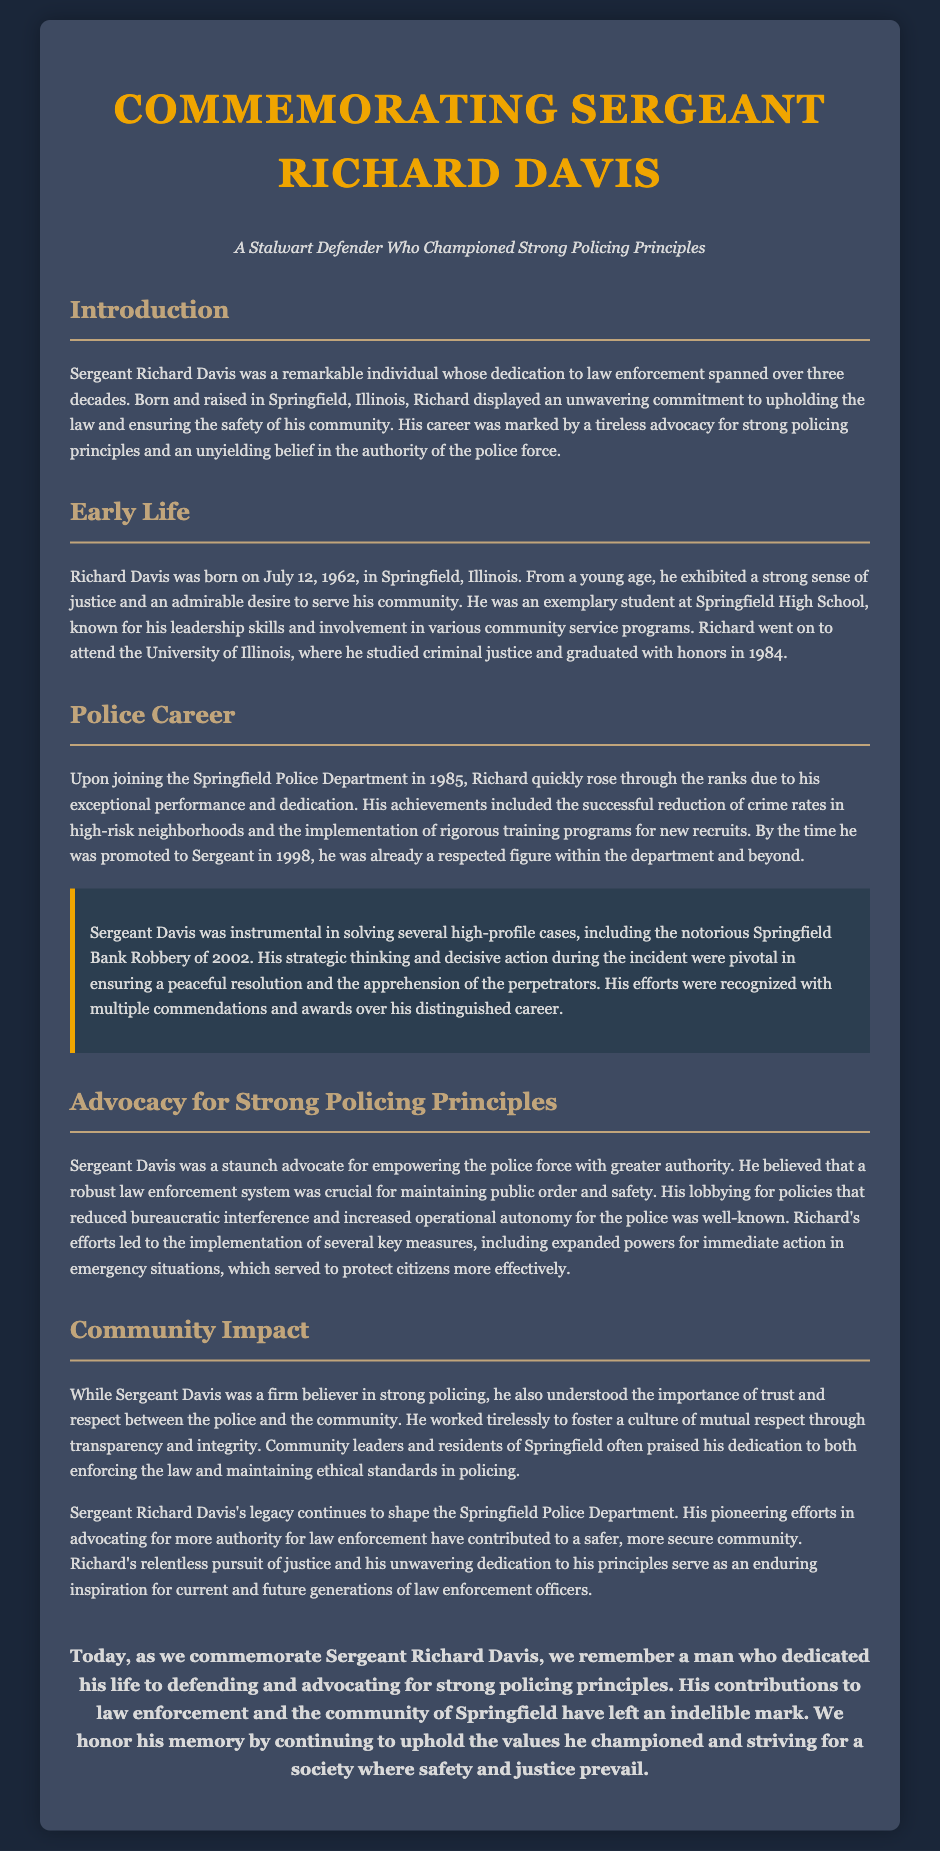what date was Sergeant Richard Davis born? The document states that Sergeant Richard Davis was born on July 12, 1962.
Answer: July 12, 1962 what was Sergeant Davis's profession? The document identifies Sergeant Richard Davis as a member of the Springfield Police Department and a Sergeant.
Answer: Sergeant what year did Sergeant Davis join the Springfield Police Department? The document mentions that he joined the department in 1985.
Answer: 1985 which high-profile case did Sergeant Davis solve in 2002? According to the document, he was instrumental in solving the Springfield Bank Robbery.
Answer: Springfield Bank Robbery what was one of Sergeant Davis's key advocacy points? The document highlights that he advocated for empowering the police force with greater authority.
Answer: Greater authority how long did Sergeant Davis serve in law enforcement? The document states that his dedication to law enforcement spanned over three decades.
Answer: Over three decades how did Sergeant Davis believe public order should be maintained? The document indicates that he believed a robust law enforcement system was crucial for maintaining public order.
Answer: Robust law enforcement system what legacy did Sergeant Davis leave on the Springfield Police Department? The document states that his pioneering efforts contributed to a safer, more secure community.
Answer: Safer, more secure community what qualities did Sergeant Davis embody that earned him community respect? The document mentions transparency and integrity as qualities he fostered in the police-community relationship.
Answer: Transparency and integrity 